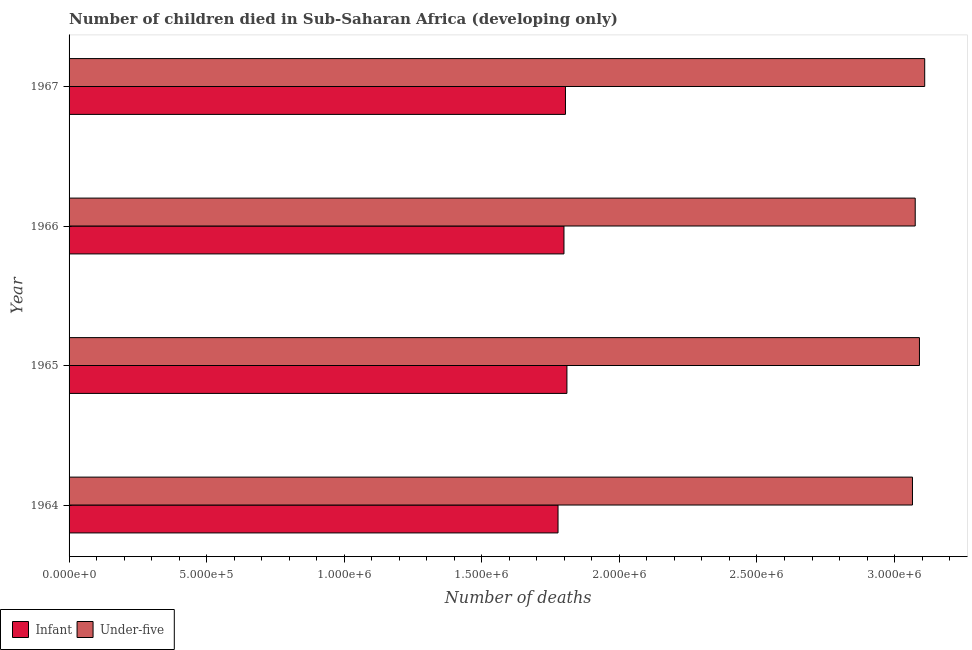Are the number of bars per tick equal to the number of legend labels?
Offer a terse response. Yes. Are the number of bars on each tick of the Y-axis equal?
Offer a terse response. Yes. How many bars are there on the 4th tick from the top?
Make the answer very short. 2. What is the label of the 2nd group of bars from the top?
Your answer should be compact. 1966. What is the number of infant deaths in 1967?
Offer a very short reply. 1.80e+06. Across all years, what is the maximum number of infant deaths?
Make the answer very short. 1.81e+06. Across all years, what is the minimum number of under-five deaths?
Keep it short and to the point. 3.07e+06. In which year was the number of infant deaths maximum?
Provide a succinct answer. 1965. In which year was the number of infant deaths minimum?
Provide a succinct answer. 1964. What is the total number of infant deaths in the graph?
Ensure brevity in your answer.  7.19e+06. What is the difference between the number of infant deaths in 1964 and that in 1967?
Offer a terse response. -2.70e+04. What is the difference between the number of under-five deaths in 1966 and the number of infant deaths in 1967?
Provide a succinct answer. 1.27e+06. What is the average number of infant deaths per year?
Offer a terse response. 1.80e+06. In the year 1964, what is the difference between the number of infant deaths and number of under-five deaths?
Provide a short and direct response. -1.29e+06. What is the ratio of the number of infant deaths in 1964 to that in 1966?
Offer a very short reply. 0.99. Is the number of under-five deaths in 1964 less than that in 1967?
Make the answer very short. Yes. What is the difference between the highest and the second highest number of under-five deaths?
Make the answer very short. 1.91e+04. What is the difference between the highest and the lowest number of infant deaths?
Give a very brief answer. 3.23e+04. Is the sum of the number of under-five deaths in 1964 and 1965 greater than the maximum number of infant deaths across all years?
Offer a very short reply. Yes. What does the 2nd bar from the top in 1966 represents?
Keep it short and to the point. Infant. What does the 1st bar from the bottom in 1966 represents?
Your answer should be compact. Infant. How many bars are there?
Give a very brief answer. 8. Are all the bars in the graph horizontal?
Your answer should be very brief. Yes. Are the values on the major ticks of X-axis written in scientific E-notation?
Give a very brief answer. Yes. Does the graph contain any zero values?
Your answer should be compact. No. Does the graph contain grids?
Provide a short and direct response. No. How are the legend labels stacked?
Your answer should be compact. Horizontal. What is the title of the graph?
Offer a terse response. Number of children died in Sub-Saharan Africa (developing only). Does "National Visitors" appear as one of the legend labels in the graph?
Provide a succinct answer. No. What is the label or title of the X-axis?
Your answer should be compact. Number of deaths. What is the label or title of the Y-axis?
Offer a terse response. Year. What is the Number of deaths of Infant in 1964?
Provide a succinct answer. 1.78e+06. What is the Number of deaths of Under-five in 1964?
Your answer should be very brief. 3.07e+06. What is the Number of deaths of Infant in 1965?
Make the answer very short. 1.81e+06. What is the Number of deaths in Under-five in 1965?
Your answer should be very brief. 3.09e+06. What is the Number of deaths in Infant in 1966?
Your response must be concise. 1.80e+06. What is the Number of deaths in Under-five in 1966?
Give a very brief answer. 3.08e+06. What is the Number of deaths in Infant in 1967?
Your answer should be compact. 1.80e+06. What is the Number of deaths in Under-five in 1967?
Keep it short and to the point. 3.11e+06. Across all years, what is the maximum Number of deaths of Infant?
Give a very brief answer. 1.81e+06. Across all years, what is the maximum Number of deaths of Under-five?
Ensure brevity in your answer.  3.11e+06. Across all years, what is the minimum Number of deaths in Infant?
Provide a succinct answer. 1.78e+06. Across all years, what is the minimum Number of deaths of Under-five?
Offer a very short reply. 3.07e+06. What is the total Number of deaths of Infant in the graph?
Make the answer very short. 7.19e+06. What is the total Number of deaths of Under-five in the graph?
Give a very brief answer. 1.23e+07. What is the difference between the Number of deaths of Infant in 1964 and that in 1965?
Keep it short and to the point. -3.23e+04. What is the difference between the Number of deaths in Under-five in 1964 and that in 1965?
Give a very brief answer. -2.54e+04. What is the difference between the Number of deaths in Infant in 1964 and that in 1966?
Your answer should be compact. -2.16e+04. What is the difference between the Number of deaths of Under-five in 1964 and that in 1966?
Keep it short and to the point. -9993. What is the difference between the Number of deaths of Infant in 1964 and that in 1967?
Your answer should be compact. -2.70e+04. What is the difference between the Number of deaths in Under-five in 1964 and that in 1967?
Provide a succinct answer. -4.45e+04. What is the difference between the Number of deaths in Infant in 1965 and that in 1966?
Offer a very short reply. 1.08e+04. What is the difference between the Number of deaths of Under-five in 1965 and that in 1966?
Your response must be concise. 1.54e+04. What is the difference between the Number of deaths of Infant in 1965 and that in 1967?
Give a very brief answer. 5322. What is the difference between the Number of deaths of Under-five in 1965 and that in 1967?
Give a very brief answer. -1.91e+04. What is the difference between the Number of deaths in Infant in 1966 and that in 1967?
Keep it short and to the point. -5445. What is the difference between the Number of deaths in Under-five in 1966 and that in 1967?
Make the answer very short. -3.45e+04. What is the difference between the Number of deaths of Infant in 1964 and the Number of deaths of Under-five in 1965?
Your response must be concise. -1.31e+06. What is the difference between the Number of deaths of Infant in 1964 and the Number of deaths of Under-five in 1966?
Make the answer very short. -1.30e+06. What is the difference between the Number of deaths of Infant in 1964 and the Number of deaths of Under-five in 1967?
Give a very brief answer. -1.33e+06. What is the difference between the Number of deaths in Infant in 1965 and the Number of deaths in Under-five in 1966?
Keep it short and to the point. -1.27e+06. What is the difference between the Number of deaths of Infant in 1965 and the Number of deaths of Under-five in 1967?
Make the answer very short. -1.30e+06. What is the difference between the Number of deaths of Infant in 1966 and the Number of deaths of Under-five in 1967?
Make the answer very short. -1.31e+06. What is the average Number of deaths in Infant per year?
Ensure brevity in your answer.  1.80e+06. What is the average Number of deaths in Under-five per year?
Provide a succinct answer. 3.09e+06. In the year 1964, what is the difference between the Number of deaths in Infant and Number of deaths in Under-five?
Give a very brief answer. -1.29e+06. In the year 1965, what is the difference between the Number of deaths of Infant and Number of deaths of Under-five?
Your response must be concise. -1.28e+06. In the year 1966, what is the difference between the Number of deaths of Infant and Number of deaths of Under-five?
Your answer should be compact. -1.28e+06. In the year 1967, what is the difference between the Number of deaths of Infant and Number of deaths of Under-five?
Your answer should be compact. -1.31e+06. What is the ratio of the Number of deaths of Infant in 1964 to that in 1965?
Give a very brief answer. 0.98. What is the ratio of the Number of deaths in Under-five in 1964 to that in 1965?
Offer a very short reply. 0.99. What is the ratio of the Number of deaths of Infant in 1964 to that in 1966?
Make the answer very short. 0.99. What is the ratio of the Number of deaths in Under-five in 1964 to that in 1966?
Make the answer very short. 1. What is the ratio of the Number of deaths in Under-five in 1964 to that in 1967?
Offer a very short reply. 0.99. What is the ratio of the Number of deaths in Infant in 1965 to that in 1966?
Your answer should be compact. 1.01. What is the ratio of the Number of deaths of Under-five in 1966 to that in 1967?
Give a very brief answer. 0.99. What is the difference between the highest and the second highest Number of deaths in Infant?
Provide a succinct answer. 5322. What is the difference between the highest and the second highest Number of deaths in Under-five?
Your answer should be compact. 1.91e+04. What is the difference between the highest and the lowest Number of deaths in Infant?
Your answer should be compact. 3.23e+04. What is the difference between the highest and the lowest Number of deaths in Under-five?
Your answer should be compact. 4.45e+04. 